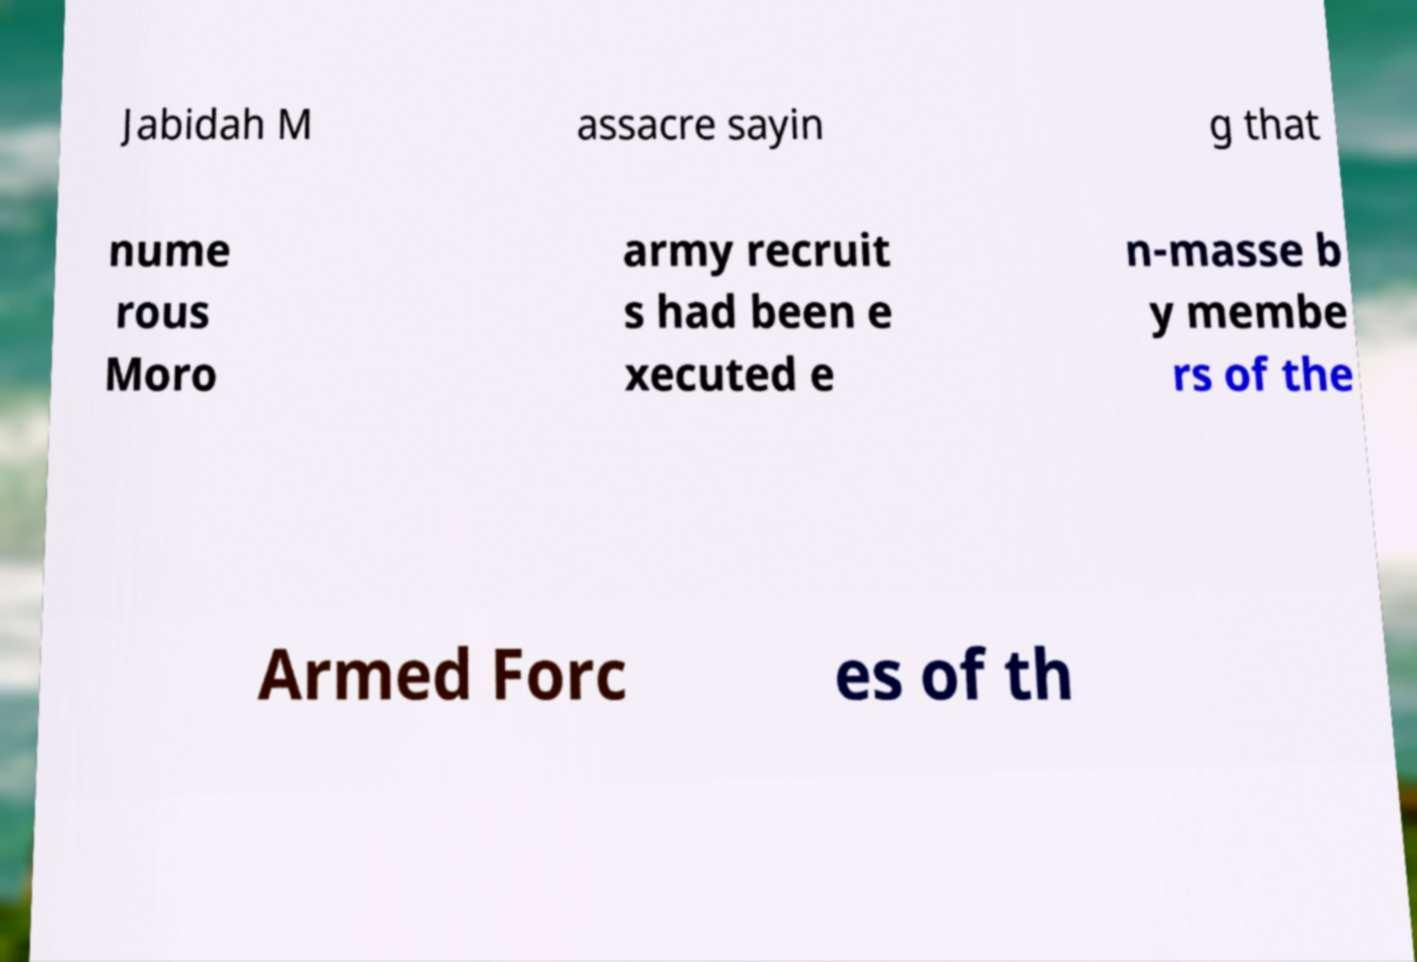Could you extract and type out the text from this image? Jabidah M assacre sayin g that nume rous Moro army recruit s had been e xecuted e n-masse b y membe rs of the Armed Forc es of th 